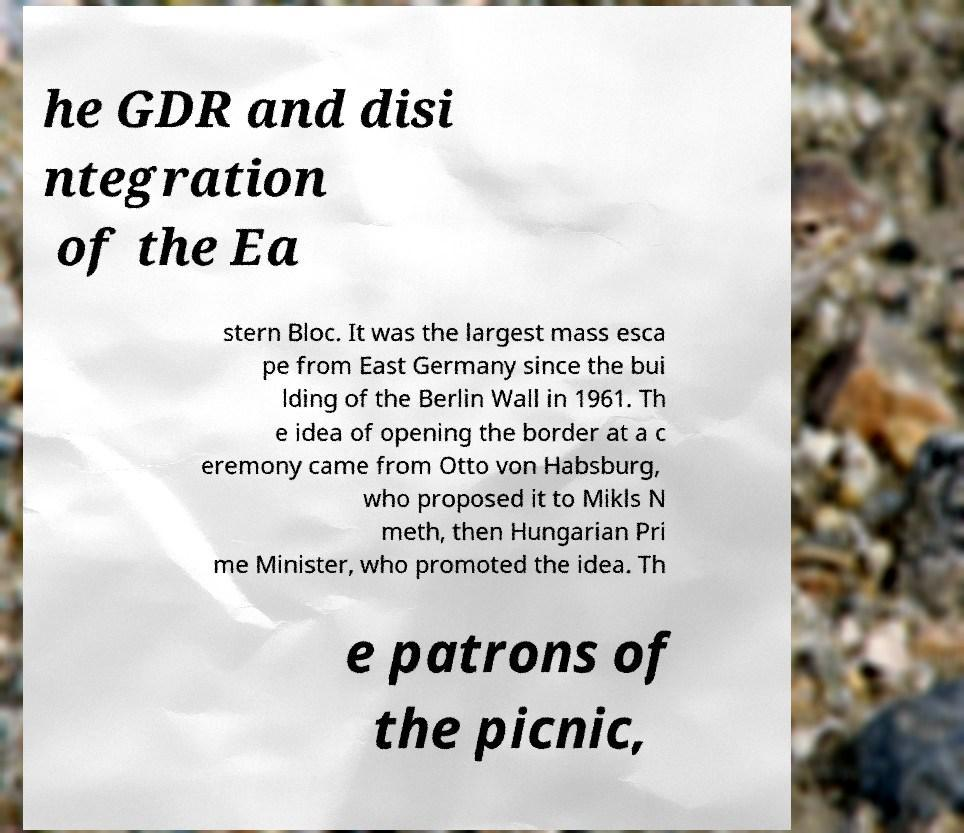There's text embedded in this image that I need extracted. Can you transcribe it verbatim? he GDR and disi ntegration of the Ea stern Bloc. It was the largest mass esca pe from East Germany since the bui lding of the Berlin Wall in 1961. Th e idea of opening the border at a c eremony came from Otto von Habsburg, who proposed it to Mikls N meth, then Hungarian Pri me Minister, who promoted the idea. Th e patrons of the picnic, 